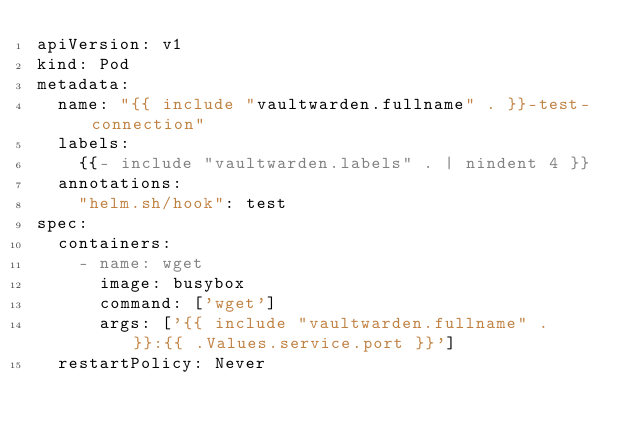Convert code to text. <code><loc_0><loc_0><loc_500><loc_500><_YAML_>apiVersion: v1
kind: Pod
metadata:
  name: "{{ include "vaultwarden.fullname" . }}-test-connection"
  labels:
    {{- include "vaultwarden.labels" . | nindent 4 }}
  annotations:
    "helm.sh/hook": test
spec:
  containers:
    - name: wget
      image: busybox
      command: ['wget']
      args: ['{{ include "vaultwarden.fullname" . }}:{{ .Values.service.port }}']
  restartPolicy: Never
</code> 